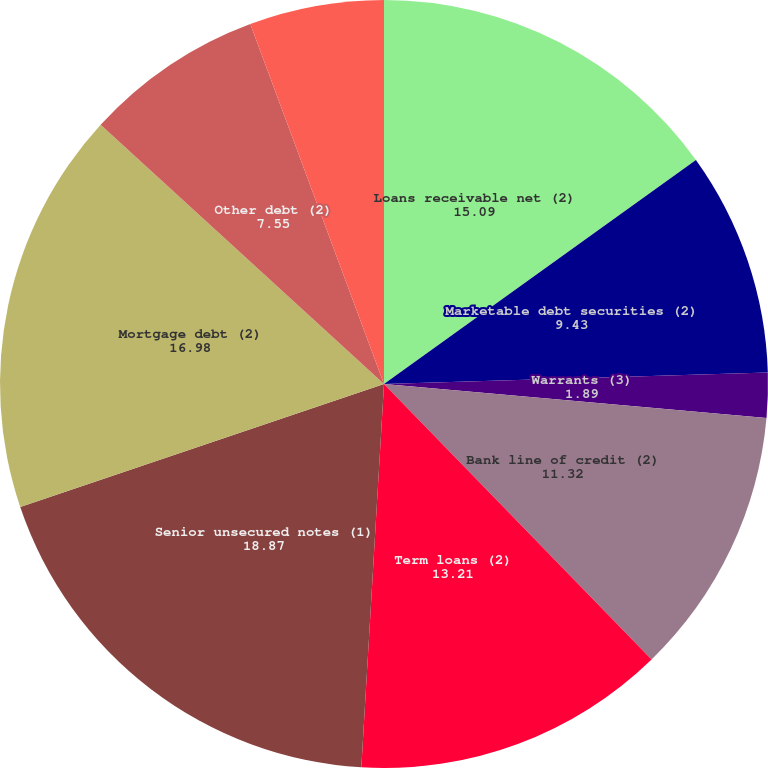Convert chart. <chart><loc_0><loc_0><loc_500><loc_500><pie_chart><fcel>Loans receivable net (2)<fcel>Marketable debt securities (2)<fcel>Marketable equity securities<fcel>Warrants (3)<fcel>Bank line of credit (2)<fcel>Term loans (2)<fcel>Senior unsecured notes (1)<fcel>Mortgage debt (2)<fcel>Other debt (2)<fcel>Interest-rate swap liabilities<nl><fcel>15.09%<fcel>9.43%<fcel>0.0%<fcel>1.89%<fcel>11.32%<fcel>13.21%<fcel>18.87%<fcel>16.98%<fcel>7.55%<fcel>5.66%<nl></chart> 